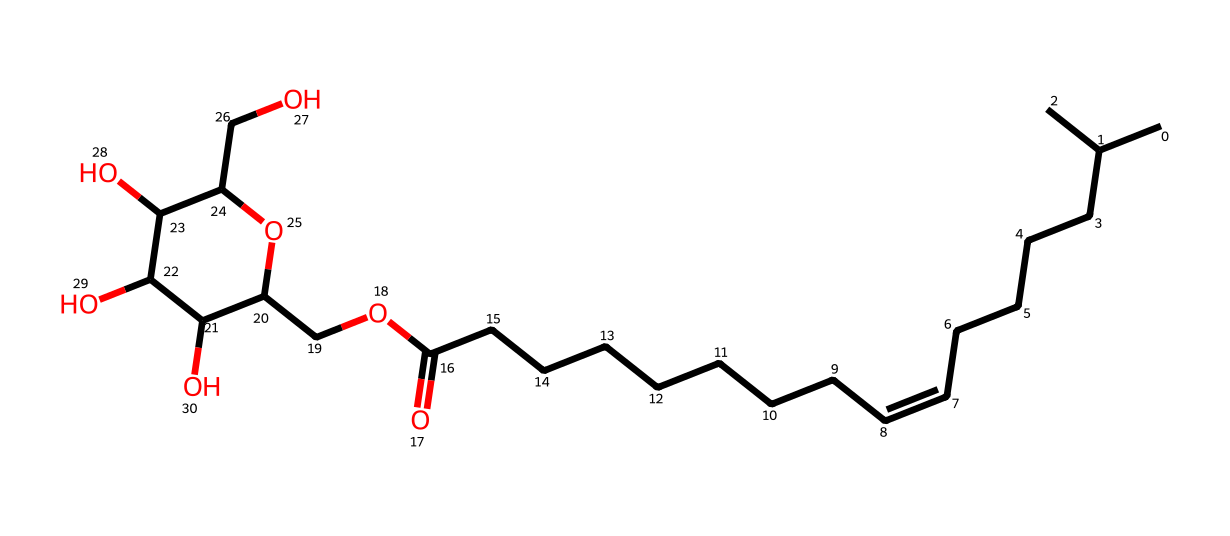What is the main functional group present in sorbitan monooleate? The SMILES representation indicates the presence of both an ester group (OCC) and a hydroxyl group (due to presence of multiple -OH groups). However, the dominant functional group that characterizes the structure is the ester as it involves the reaction between the alcohol component from sorbitan and the fatty acid, oleic acid.
Answer: ester How many hydroxyl groups are present in sorbitan monooleate? By examining the structure represented in the SMILES, there are three -OH (hydroxyl) groups in the molecule, as indicated by the segments that show alcohol functionalities connected to the sugar-like structure.
Answer: three What type of surfactant is sorbitan monooleate? Sorbitan monooleate is a non-ionic surfactant, which means it does not carry a net electrical charge, unlike ionic surfactants. This conclusion derives from the presence of hydroxyl groups rather than ionic groups like -COO− or -SO3− in its structure.
Answer: non-ionic What does the presence of a double bond in the hydrocarbon chain signify? The double bond in the hydrocarbon chain, represented as /C=C\, typically indicates unsaturation, which can affect the physical properties of the surfactant, such as its flexibility and interactions with other molecules. Unsaturated fatty acids can also contribute to lower viscosities and better emulsification properties.
Answer: unsaturation What is the total number of carbon atoms in sorbitan monooleate? By analyzing the SMILES representation, you can count a total of 21 carbon atoms (CC(C) indicates the branched chain, and the linear segments add to the total), verifying the chain lengths and branching structures present in the depiction.
Answer: twenty-one Which part of the chemical structure is responsible for its emulsifying properties? The hydrophobic tail composed of the long hydrocarbon chain (the alkyl part of the fatty acid) along with the polar head, which includes hydroxyl groups, assists in forming micelles. The amphiphilic nature due to this arrangement allows it to reduce surface tension and stabilize emulsions, giving sorbitan monooleate its emulsifying properties.
Answer: alkyl chain and hydroxyl groups 